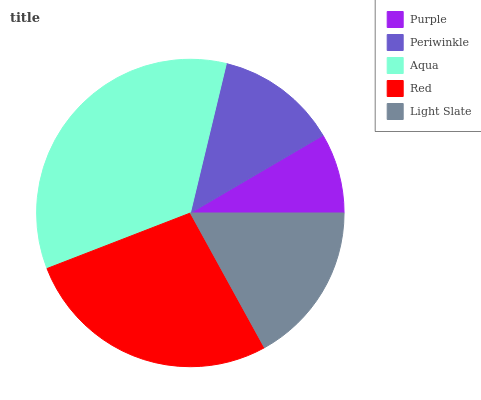Is Purple the minimum?
Answer yes or no. Yes. Is Aqua the maximum?
Answer yes or no. Yes. Is Periwinkle the minimum?
Answer yes or no. No. Is Periwinkle the maximum?
Answer yes or no. No. Is Periwinkle greater than Purple?
Answer yes or no. Yes. Is Purple less than Periwinkle?
Answer yes or no. Yes. Is Purple greater than Periwinkle?
Answer yes or no. No. Is Periwinkle less than Purple?
Answer yes or no. No. Is Light Slate the high median?
Answer yes or no. Yes. Is Light Slate the low median?
Answer yes or no. Yes. Is Purple the high median?
Answer yes or no. No. Is Periwinkle the low median?
Answer yes or no. No. 